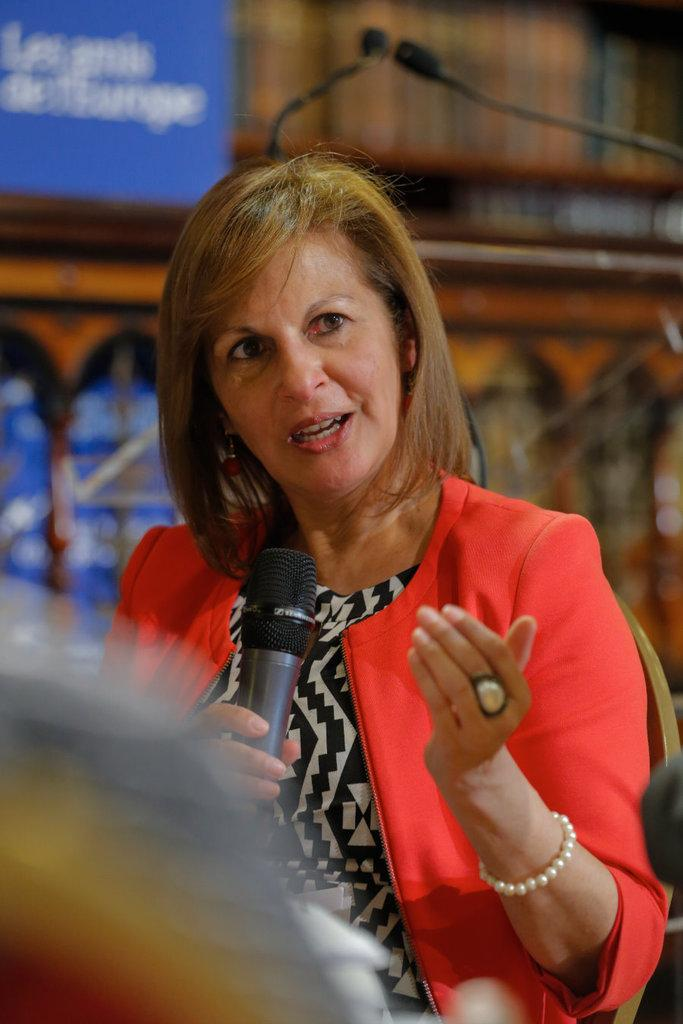Who is the main subject in the image? There is a woman in the image. What is the woman doing in the image? The woman is seated on a chair and speaking into a microphone. What type of hen can be seen perched on the microphone in the image? There is no hen present in the image; the woman is speaking into a microphone. 